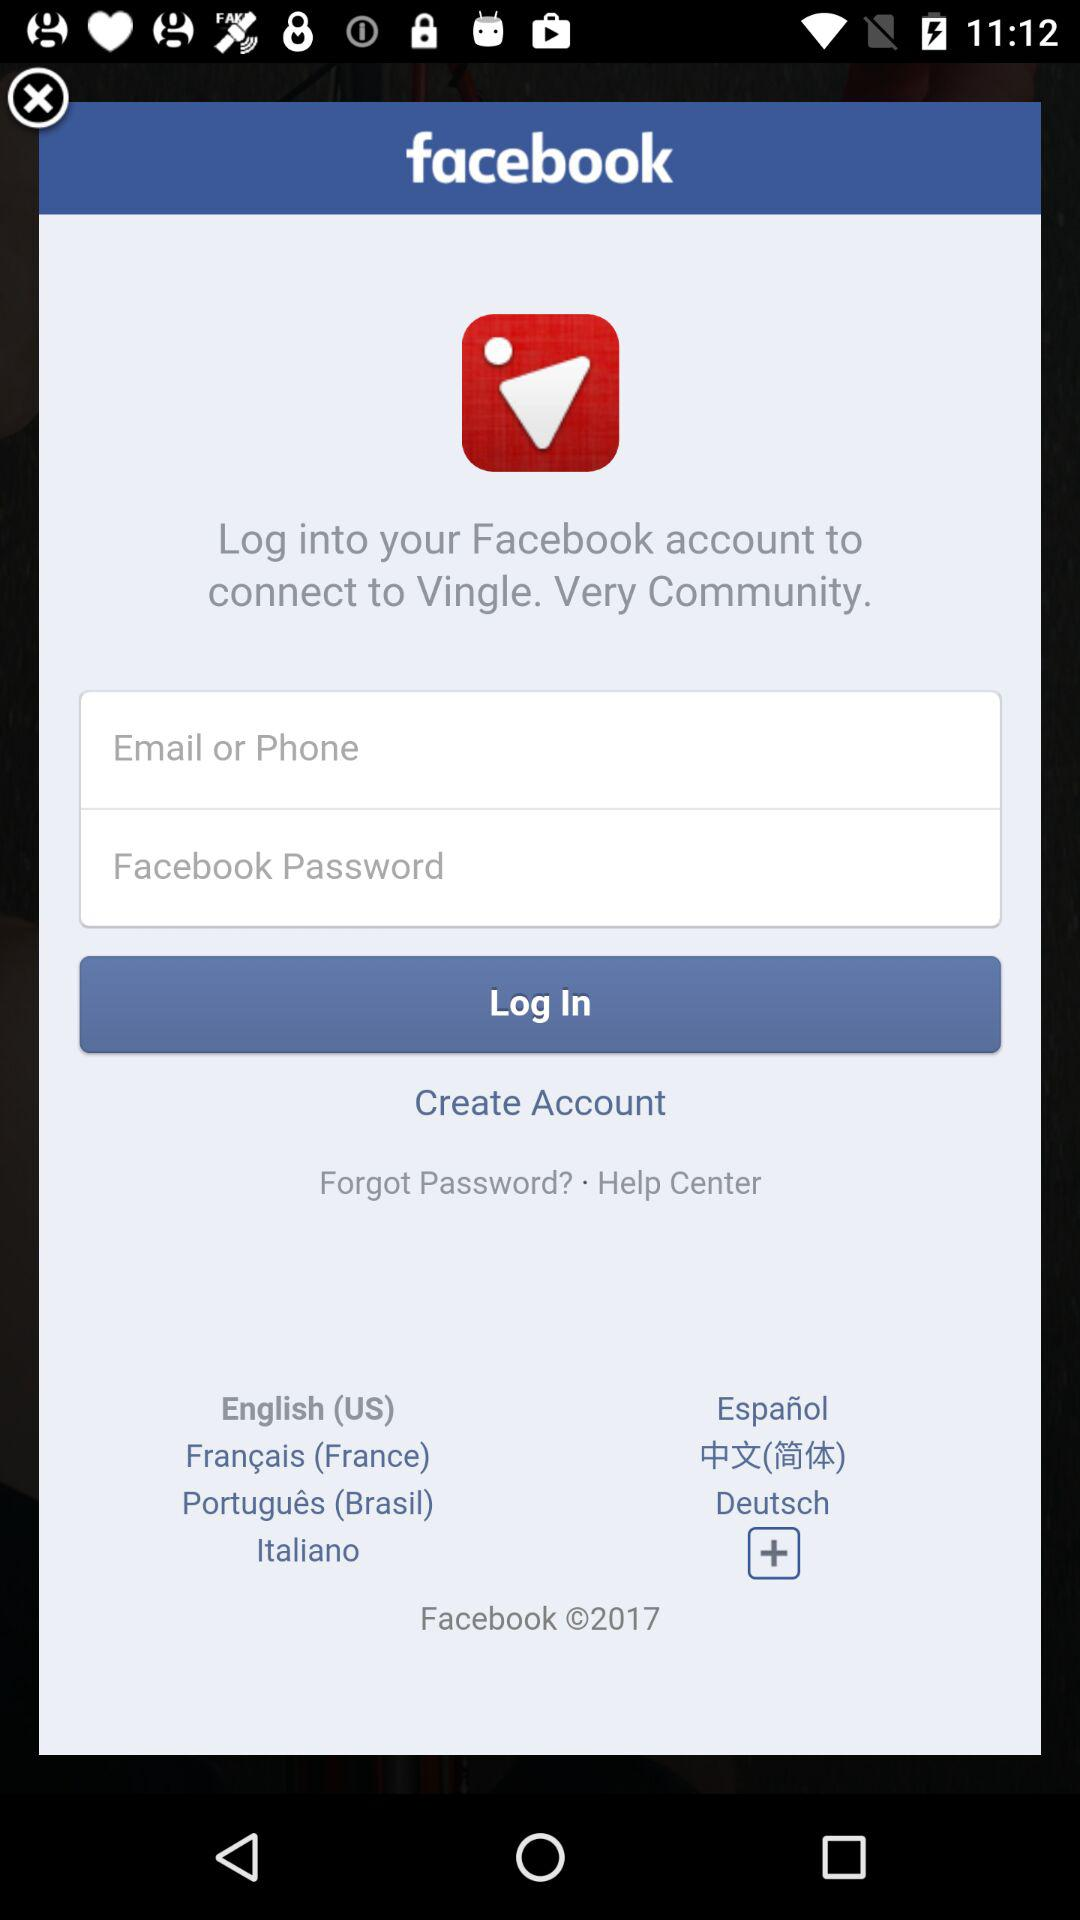For what app can you log into your "Facebook" account? You can log into your "Facebook" account for the "Vingle. Very Community." app. 